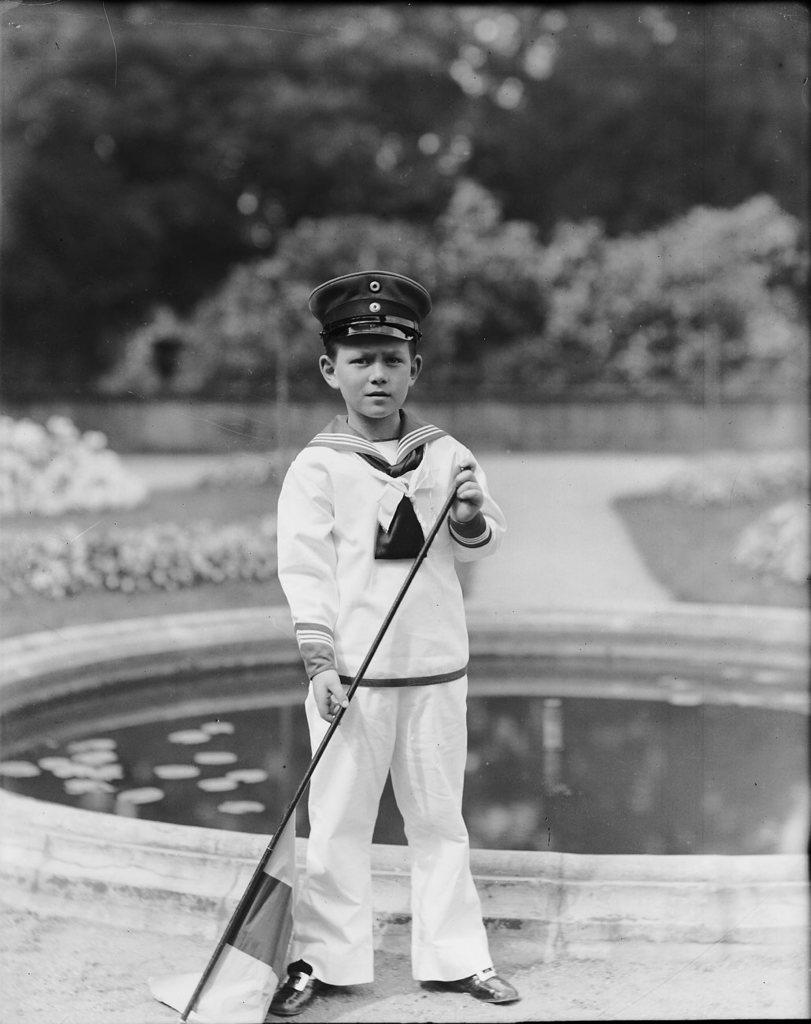Can you describe this image briefly? In this picture I can see a boy in front who is standing and I see that he is holding a flag in his hands. In the middle of this picture I can see a pond. In the background I can see the planets and I see that it is blurred. 